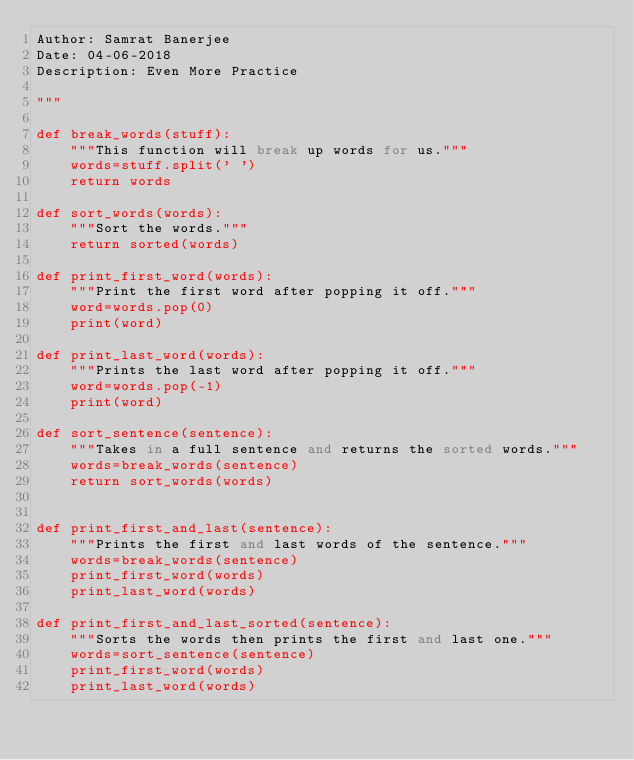<code> <loc_0><loc_0><loc_500><loc_500><_Python_>Author: Samrat Banerjee
Date: 04-06-2018
Description: Even More Practice

"""

def break_words(stuff):
    """This function will break up words for us."""
    words=stuff.split(' ')
    return words

def sort_words(words):
    """Sort the words."""
    return sorted(words)

def print_first_word(words):
    """Print the first word after popping it off."""
    word=words.pop(0)
    print(word)

def print_last_word(words):
    """Prints the last word after popping it off."""
    word=words.pop(-1)
    print(word)

def sort_sentence(sentence):
    """Takes in a full sentence and returns the sorted words."""
    words=break_words(sentence)
    return sort_words(words)


def print_first_and_last(sentence):
    """Prints the first and last words of the sentence."""
    words=break_words(sentence)
    print_first_word(words)
    print_last_word(words)

def print_first_and_last_sorted(sentence):
    """Sorts the words then prints the first and last one."""
    words=sort_sentence(sentence)
    print_first_word(words)
    print_last_word(words)
</code> 